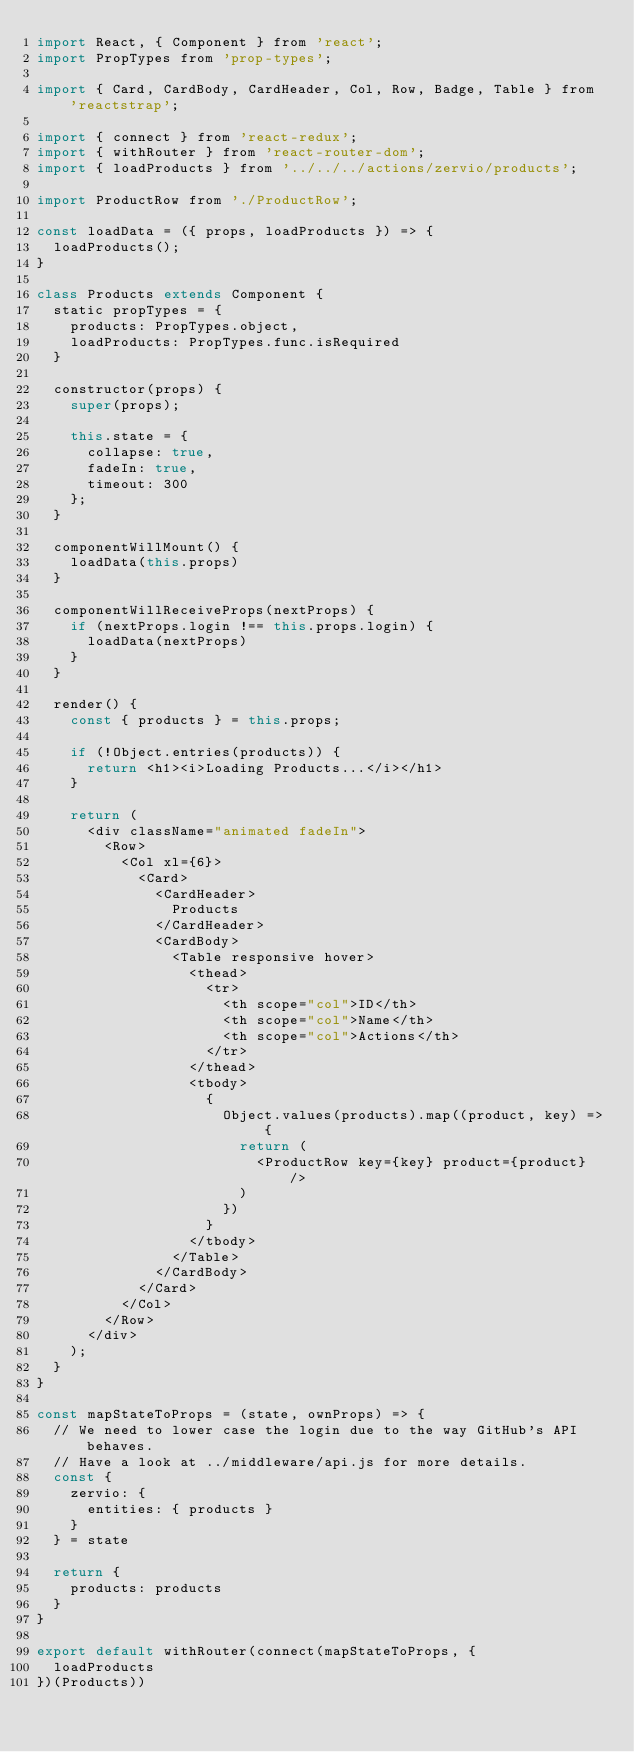<code> <loc_0><loc_0><loc_500><loc_500><_JavaScript_>import React, { Component } from 'react';
import PropTypes from 'prop-types';

import { Card, CardBody, CardHeader, Col, Row, Badge, Table } from 'reactstrap';

import { connect } from 'react-redux';
import { withRouter } from 'react-router-dom';
import { loadProducts } from '../../../actions/zervio/products';

import ProductRow from './ProductRow';

const loadData = ({ props, loadProducts }) => {
  loadProducts();
}

class Products extends Component {
  static propTypes = {
    products: PropTypes.object,
    loadProducts: PropTypes.func.isRequired
  }

  constructor(props) {
    super(props);

    this.state = {
      collapse: true,
      fadeIn: true,
      timeout: 300
    };
  }

  componentWillMount() {
    loadData(this.props)
  }

  componentWillReceiveProps(nextProps) {
    if (nextProps.login !== this.props.login) {
      loadData(nextProps)
    }
  }

  render() {
    const { products } = this.props;

    if (!Object.entries(products)) {
      return <h1><i>Loading Products...</i></h1>
    }

    return (
      <div className="animated fadeIn">
        <Row>
          <Col xl={6}>
            <Card>
              <CardHeader>
                Products
              </CardHeader>
              <CardBody>
                <Table responsive hover>
                  <thead>
                    <tr>
                      <th scope="col">ID</th>
                      <th scope="col">Name</th>
                      <th scope="col">Actions</th>
                    </tr>
                  </thead>
                  <tbody>
                    {
                      Object.values(products).map((product, key) => {
                        return (
                          <ProductRow key={key} product={product} />
                        )
                      })
                    }
                  </tbody>
                </Table>
              </CardBody>
            </Card>
          </Col>
        </Row>
      </div>
    );
  }
}

const mapStateToProps = (state, ownProps) => {
  // We need to lower case the login due to the way GitHub's API behaves.
  // Have a look at ../middleware/api.js for more details.
  const {
    zervio: {
      entities: { products }
    }
  } = state

  return {
    products: products
  }
}

export default withRouter(connect(mapStateToProps, {
  loadProducts
})(Products))
</code> 